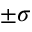<formula> <loc_0><loc_0><loc_500><loc_500>\pm \sigma</formula> 